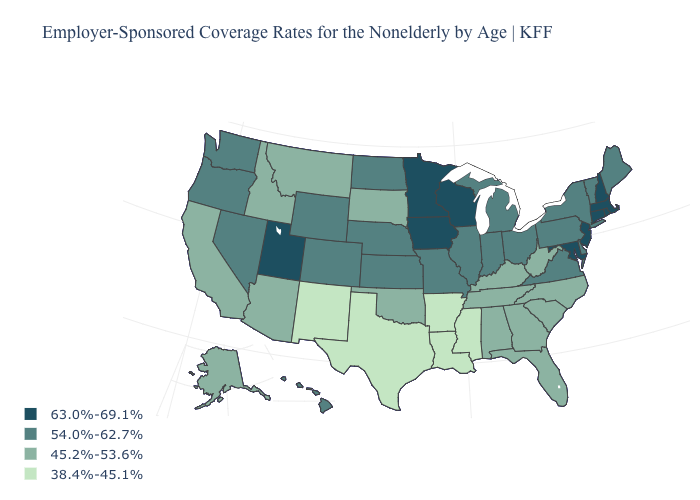Name the states that have a value in the range 38.4%-45.1%?
Be succinct. Arkansas, Louisiana, Mississippi, New Mexico, Texas. Does the first symbol in the legend represent the smallest category?
Be succinct. No. Name the states that have a value in the range 54.0%-62.7%?
Write a very short answer. Colorado, Delaware, Hawaii, Illinois, Indiana, Kansas, Maine, Michigan, Missouri, Nebraska, Nevada, New York, North Dakota, Ohio, Oregon, Pennsylvania, Vermont, Virginia, Washington, Wyoming. What is the value of North Carolina?
Write a very short answer. 45.2%-53.6%. Does Pennsylvania have the same value as Nebraska?
Short answer required. Yes. Among the states that border Montana , does North Dakota have the lowest value?
Short answer required. No. How many symbols are there in the legend?
Short answer required. 4. Does Pennsylvania have the highest value in the USA?
Be succinct. No. What is the lowest value in states that border Illinois?
Short answer required. 45.2%-53.6%. What is the highest value in the USA?
Keep it brief. 63.0%-69.1%. What is the value of South Carolina?
Keep it brief. 45.2%-53.6%. What is the value of Indiana?
Concise answer only. 54.0%-62.7%. What is the highest value in the USA?
Concise answer only. 63.0%-69.1%. Which states have the lowest value in the USA?
Give a very brief answer. Arkansas, Louisiana, Mississippi, New Mexico, Texas. Does Wisconsin have the highest value in the MidWest?
Write a very short answer. Yes. 